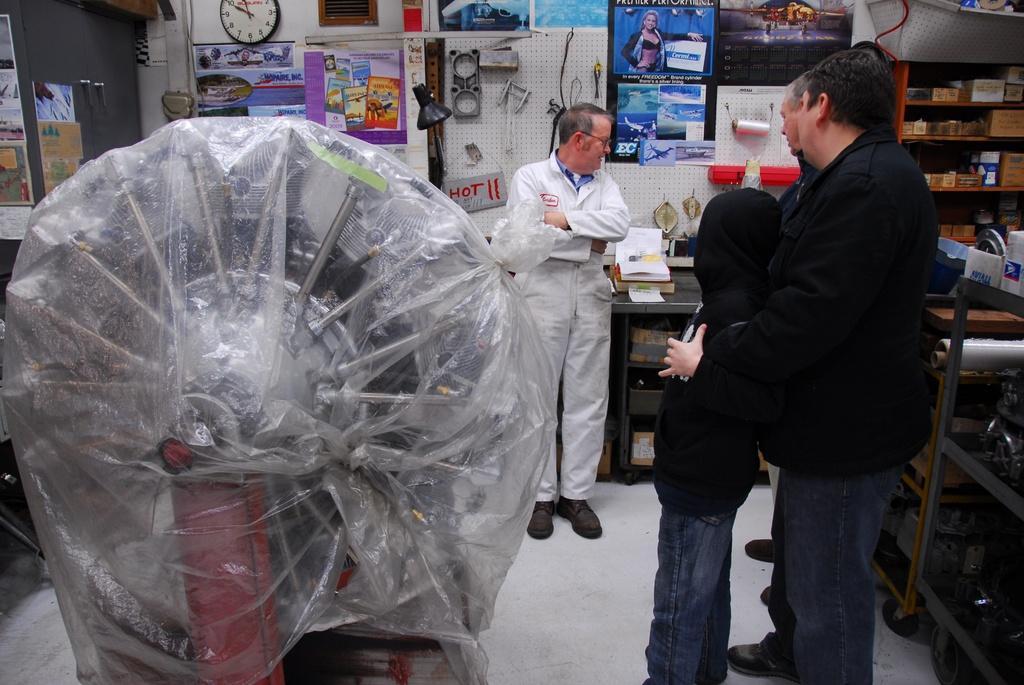Please provide a concise description of this image. In front of the image there is some metal object, beside the object there are a few people standing, around them there are a few objects on the tables, there are some objects on the walls and shelves behind them. 